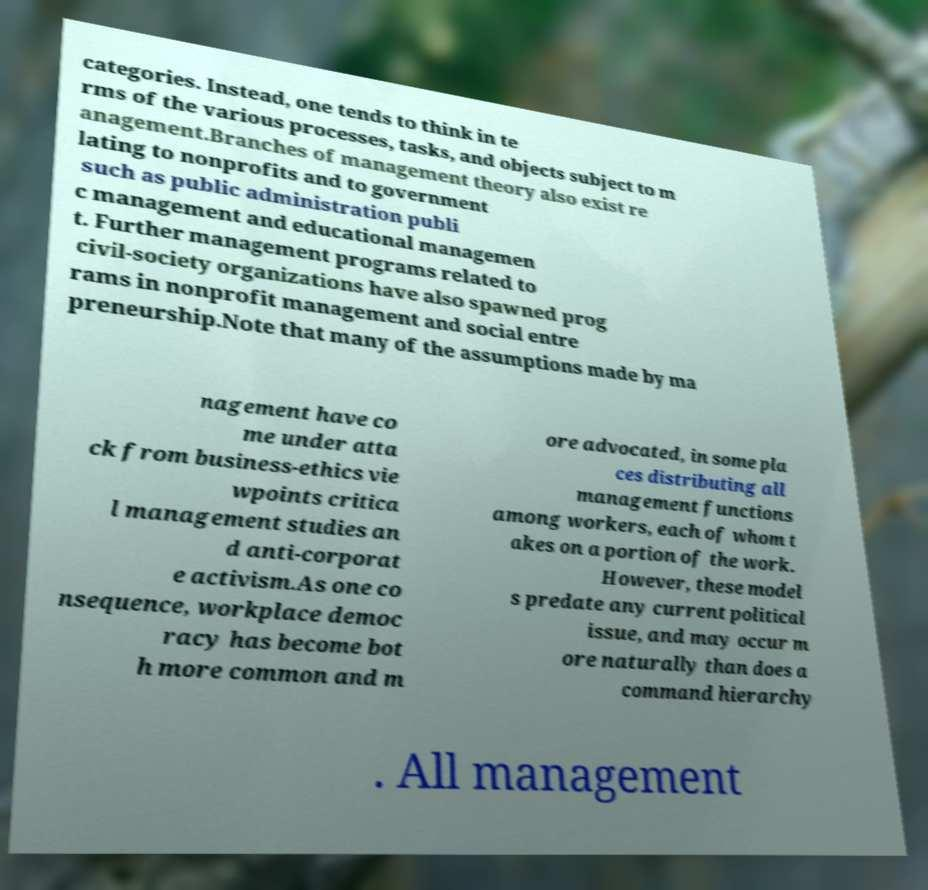What messages or text are displayed in this image? I need them in a readable, typed format. categories. Instead, one tends to think in te rms of the various processes, tasks, and objects subject to m anagement.Branches of management theory also exist re lating to nonprofits and to government such as public administration publi c management and educational managemen t. Further management programs related to civil-society organizations have also spawned prog rams in nonprofit management and social entre preneurship.Note that many of the assumptions made by ma nagement have co me under atta ck from business-ethics vie wpoints critica l management studies an d anti-corporat e activism.As one co nsequence, workplace democ racy has become bot h more common and m ore advocated, in some pla ces distributing all management functions among workers, each of whom t akes on a portion of the work. However, these model s predate any current political issue, and may occur m ore naturally than does a command hierarchy . All management 